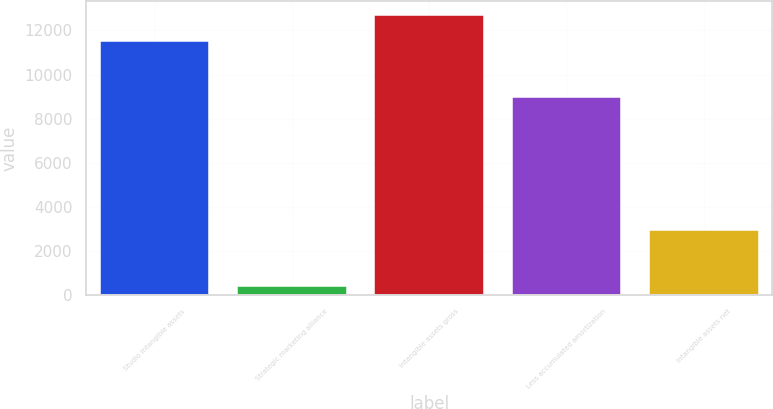Convert chart. <chart><loc_0><loc_0><loc_500><loc_500><bar_chart><fcel>Studio intangible assets<fcel>Strategic marketing alliance<fcel>Intangible assets gross<fcel>Less accumulated amortization<fcel>Intangible assets net<nl><fcel>11528<fcel>416<fcel>12680.8<fcel>8996<fcel>2948<nl></chart> 